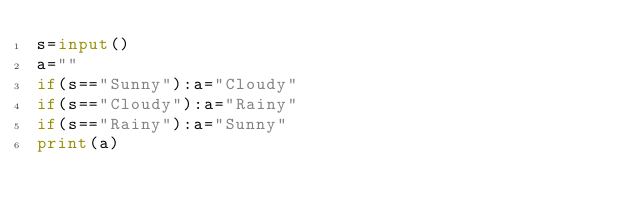Convert code to text. <code><loc_0><loc_0><loc_500><loc_500><_Python_>s=input()
a=""
if(s=="Sunny"):a="Cloudy"
if(s=="Cloudy"):a="Rainy"
if(s=="Rainy"):a="Sunny"
print(a)</code> 